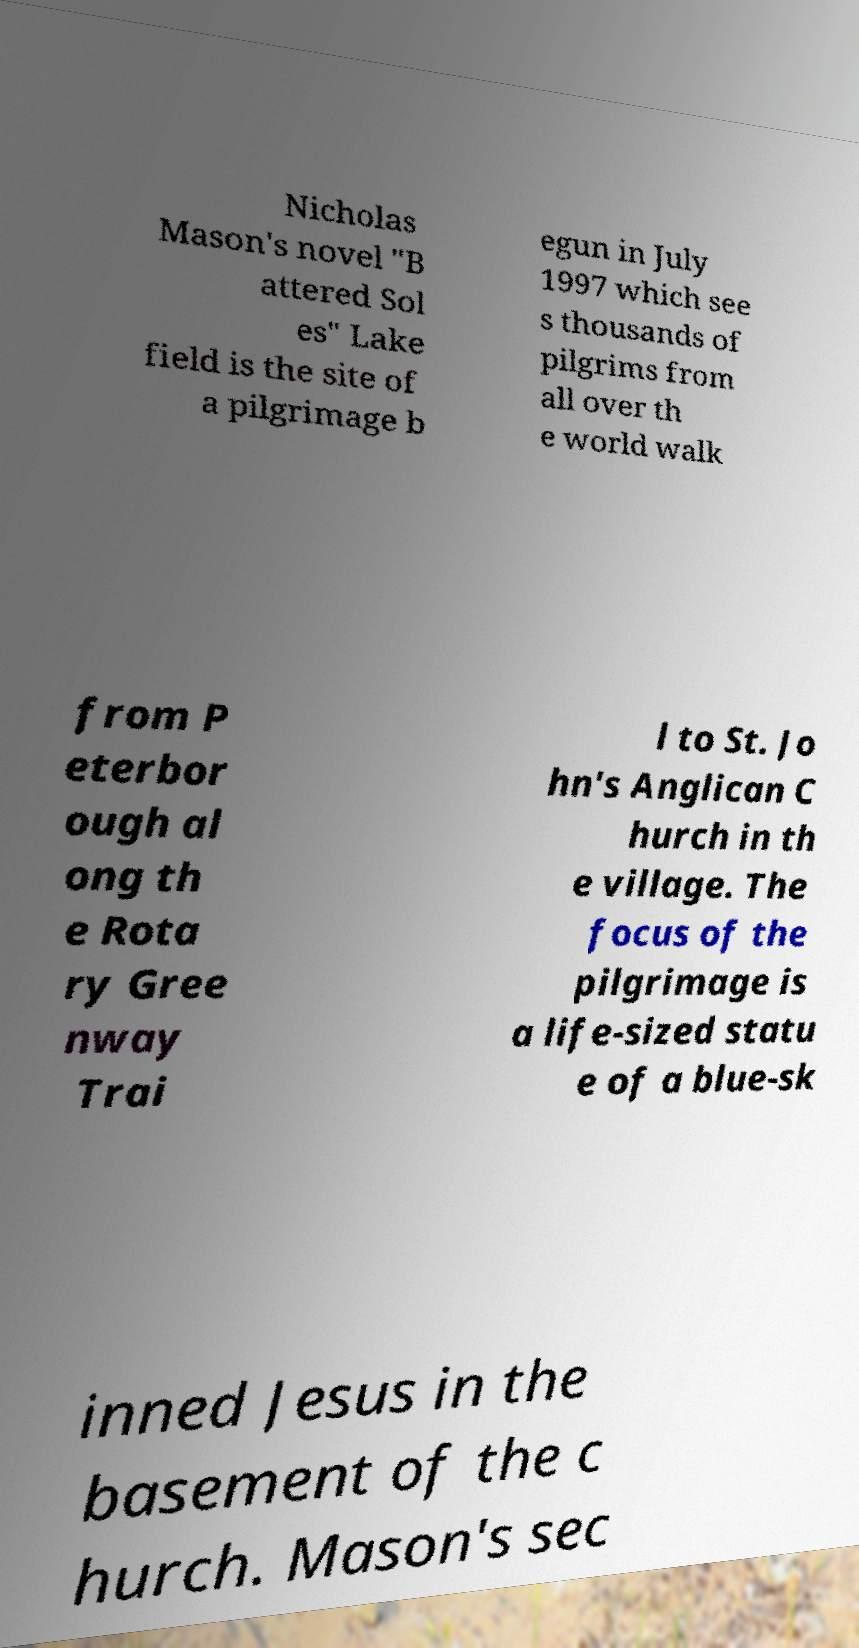What messages or text are displayed in this image? I need them in a readable, typed format. Nicholas Mason's novel "B attered Sol es" Lake field is the site of a pilgrimage b egun in July 1997 which see s thousands of pilgrims from all over th e world walk from P eterbor ough al ong th e Rota ry Gree nway Trai l to St. Jo hn's Anglican C hurch in th e village. The focus of the pilgrimage is a life-sized statu e of a blue-sk inned Jesus in the basement of the c hurch. Mason's sec 